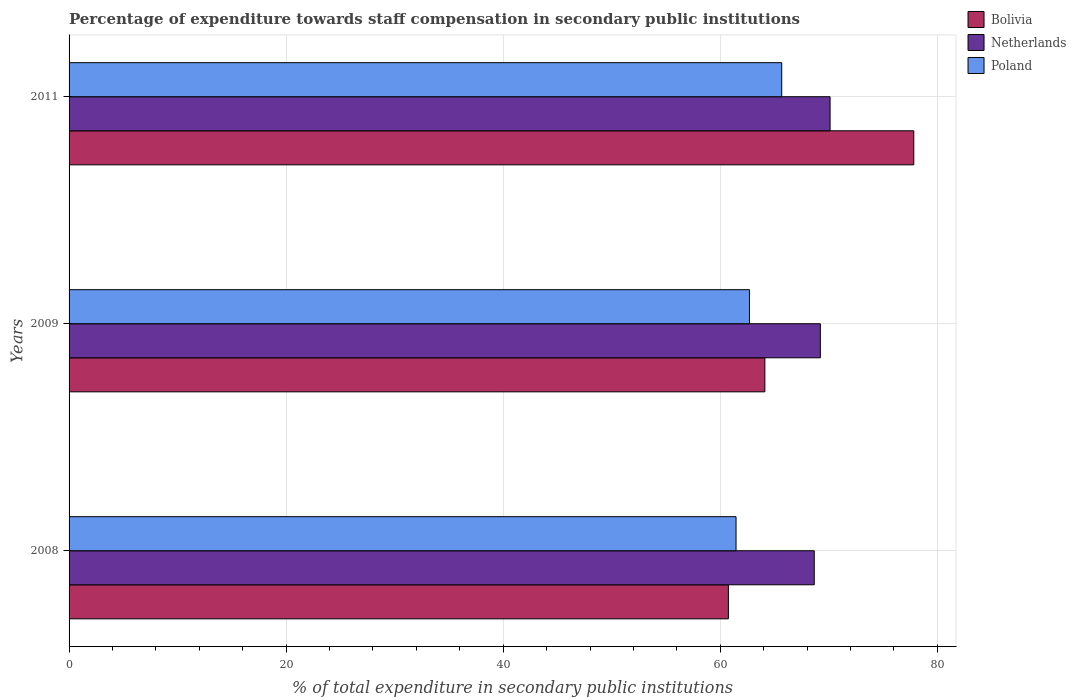How many different coloured bars are there?
Provide a succinct answer. 3. How many groups of bars are there?
Ensure brevity in your answer.  3. Are the number of bars on each tick of the Y-axis equal?
Ensure brevity in your answer.  Yes. How many bars are there on the 2nd tick from the bottom?
Ensure brevity in your answer.  3. What is the label of the 2nd group of bars from the top?
Offer a very short reply. 2009. What is the percentage of expenditure towards staff compensation in Bolivia in 2011?
Your response must be concise. 77.83. Across all years, what is the maximum percentage of expenditure towards staff compensation in Bolivia?
Your answer should be very brief. 77.83. Across all years, what is the minimum percentage of expenditure towards staff compensation in Netherlands?
Ensure brevity in your answer.  68.66. In which year was the percentage of expenditure towards staff compensation in Netherlands minimum?
Ensure brevity in your answer.  2008. What is the total percentage of expenditure towards staff compensation in Poland in the graph?
Your response must be concise. 189.8. What is the difference between the percentage of expenditure towards staff compensation in Bolivia in 2008 and that in 2011?
Give a very brief answer. -17.08. What is the difference between the percentage of expenditure towards staff compensation in Poland in 2011 and the percentage of expenditure towards staff compensation in Bolivia in 2008?
Provide a short and direct response. 4.91. What is the average percentage of expenditure towards staff compensation in Poland per year?
Your answer should be compact. 63.27. In the year 2009, what is the difference between the percentage of expenditure towards staff compensation in Poland and percentage of expenditure towards staff compensation in Bolivia?
Ensure brevity in your answer.  -1.42. What is the ratio of the percentage of expenditure towards staff compensation in Bolivia in 2009 to that in 2011?
Your answer should be compact. 0.82. Is the percentage of expenditure towards staff compensation in Bolivia in 2008 less than that in 2011?
Make the answer very short. Yes. Is the difference between the percentage of expenditure towards staff compensation in Poland in 2009 and 2011 greater than the difference between the percentage of expenditure towards staff compensation in Bolivia in 2009 and 2011?
Your answer should be very brief. Yes. What is the difference between the highest and the second highest percentage of expenditure towards staff compensation in Bolivia?
Make the answer very short. 13.72. What is the difference between the highest and the lowest percentage of expenditure towards staff compensation in Poland?
Provide a succinct answer. 4.21. Is the sum of the percentage of expenditure towards staff compensation in Bolivia in 2009 and 2011 greater than the maximum percentage of expenditure towards staff compensation in Poland across all years?
Ensure brevity in your answer.  Yes. How many bars are there?
Provide a succinct answer. 9. Are all the bars in the graph horizontal?
Give a very brief answer. Yes. What is the difference between two consecutive major ticks on the X-axis?
Give a very brief answer. 20. Where does the legend appear in the graph?
Your answer should be very brief. Top right. How are the legend labels stacked?
Keep it short and to the point. Vertical. What is the title of the graph?
Offer a terse response. Percentage of expenditure towards staff compensation in secondary public institutions. Does "Upper middle income" appear as one of the legend labels in the graph?
Offer a very short reply. No. What is the label or title of the X-axis?
Make the answer very short. % of total expenditure in secondary public institutions. What is the % of total expenditure in secondary public institutions of Bolivia in 2008?
Make the answer very short. 60.75. What is the % of total expenditure in secondary public institutions of Netherlands in 2008?
Give a very brief answer. 68.66. What is the % of total expenditure in secondary public institutions in Poland in 2008?
Ensure brevity in your answer.  61.45. What is the % of total expenditure in secondary public institutions in Bolivia in 2009?
Provide a succinct answer. 64.11. What is the % of total expenditure in secondary public institutions in Netherlands in 2009?
Offer a very short reply. 69.22. What is the % of total expenditure in secondary public institutions in Poland in 2009?
Provide a succinct answer. 62.69. What is the % of total expenditure in secondary public institutions in Bolivia in 2011?
Your response must be concise. 77.83. What is the % of total expenditure in secondary public institutions in Netherlands in 2011?
Provide a succinct answer. 70.11. What is the % of total expenditure in secondary public institutions in Poland in 2011?
Keep it short and to the point. 65.66. Across all years, what is the maximum % of total expenditure in secondary public institutions in Bolivia?
Provide a short and direct response. 77.83. Across all years, what is the maximum % of total expenditure in secondary public institutions in Netherlands?
Give a very brief answer. 70.11. Across all years, what is the maximum % of total expenditure in secondary public institutions in Poland?
Your response must be concise. 65.66. Across all years, what is the minimum % of total expenditure in secondary public institutions in Bolivia?
Offer a terse response. 60.75. Across all years, what is the minimum % of total expenditure in secondary public institutions in Netherlands?
Your answer should be very brief. 68.66. Across all years, what is the minimum % of total expenditure in secondary public institutions in Poland?
Your answer should be compact. 61.45. What is the total % of total expenditure in secondary public institutions of Bolivia in the graph?
Provide a succinct answer. 202.68. What is the total % of total expenditure in secondary public institutions of Netherlands in the graph?
Your answer should be compact. 207.99. What is the total % of total expenditure in secondary public institutions in Poland in the graph?
Provide a succinct answer. 189.8. What is the difference between the % of total expenditure in secondary public institutions in Bolivia in 2008 and that in 2009?
Your response must be concise. -3.36. What is the difference between the % of total expenditure in secondary public institutions in Netherlands in 2008 and that in 2009?
Your response must be concise. -0.56. What is the difference between the % of total expenditure in secondary public institutions in Poland in 2008 and that in 2009?
Offer a very short reply. -1.23. What is the difference between the % of total expenditure in secondary public institutions of Bolivia in 2008 and that in 2011?
Give a very brief answer. -17.08. What is the difference between the % of total expenditure in secondary public institutions in Netherlands in 2008 and that in 2011?
Give a very brief answer. -1.46. What is the difference between the % of total expenditure in secondary public institutions of Poland in 2008 and that in 2011?
Keep it short and to the point. -4.21. What is the difference between the % of total expenditure in secondary public institutions in Bolivia in 2009 and that in 2011?
Give a very brief answer. -13.72. What is the difference between the % of total expenditure in secondary public institutions of Netherlands in 2009 and that in 2011?
Give a very brief answer. -0.9. What is the difference between the % of total expenditure in secondary public institutions in Poland in 2009 and that in 2011?
Make the answer very short. -2.97. What is the difference between the % of total expenditure in secondary public institutions of Bolivia in 2008 and the % of total expenditure in secondary public institutions of Netherlands in 2009?
Your answer should be very brief. -8.47. What is the difference between the % of total expenditure in secondary public institutions in Bolivia in 2008 and the % of total expenditure in secondary public institutions in Poland in 2009?
Offer a very short reply. -1.94. What is the difference between the % of total expenditure in secondary public institutions in Netherlands in 2008 and the % of total expenditure in secondary public institutions in Poland in 2009?
Make the answer very short. 5.97. What is the difference between the % of total expenditure in secondary public institutions of Bolivia in 2008 and the % of total expenditure in secondary public institutions of Netherlands in 2011?
Your answer should be very brief. -9.37. What is the difference between the % of total expenditure in secondary public institutions in Bolivia in 2008 and the % of total expenditure in secondary public institutions in Poland in 2011?
Provide a short and direct response. -4.91. What is the difference between the % of total expenditure in secondary public institutions in Netherlands in 2008 and the % of total expenditure in secondary public institutions in Poland in 2011?
Keep it short and to the point. 3. What is the difference between the % of total expenditure in secondary public institutions in Bolivia in 2009 and the % of total expenditure in secondary public institutions in Netherlands in 2011?
Your answer should be compact. -6.01. What is the difference between the % of total expenditure in secondary public institutions in Bolivia in 2009 and the % of total expenditure in secondary public institutions in Poland in 2011?
Provide a short and direct response. -1.55. What is the difference between the % of total expenditure in secondary public institutions in Netherlands in 2009 and the % of total expenditure in secondary public institutions in Poland in 2011?
Your response must be concise. 3.56. What is the average % of total expenditure in secondary public institutions in Bolivia per year?
Your answer should be very brief. 67.56. What is the average % of total expenditure in secondary public institutions in Netherlands per year?
Offer a very short reply. 69.33. What is the average % of total expenditure in secondary public institutions of Poland per year?
Offer a very short reply. 63.27. In the year 2008, what is the difference between the % of total expenditure in secondary public institutions of Bolivia and % of total expenditure in secondary public institutions of Netherlands?
Your answer should be compact. -7.91. In the year 2008, what is the difference between the % of total expenditure in secondary public institutions of Bolivia and % of total expenditure in secondary public institutions of Poland?
Make the answer very short. -0.71. In the year 2008, what is the difference between the % of total expenditure in secondary public institutions in Netherlands and % of total expenditure in secondary public institutions in Poland?
Ensure brevity in your answer.  7.2. In the year 2009, what is the difference between the % of total expenditure in secondary public institutions in Bolivia and % of total expenditure in secondary public institutions in Netherlands?
Provide a succinct answer. -5.11. In the year 2009, what is the difference between the % of total expenditure in secondary public institutions of Bolivia and % of total expenditure in secondary public institutions of Poland?
Offer a very short reply. 1.42. In the year 2009, what is the difference between the % of total expenditure in secondary public institutions in Netherlands and % of total expenditure in secondary public institutions in Poland?
Provide a short and direct response. 6.53. In the year 2011, what is the difference between the % of total expenditure in secondary public institutions in Bolivia and % of total expenditure in secondary public institutions in Netherlands?
Offer a very short reply. 7.71. In the year 2011, what is the difference between the % of total expenditure in secondary public institutions in Bolivia and % of total expenditure in secondary public institutions in Poland?
Your response must be concise. 12.17. In the year 2011, what is the difference between the % of total expenditure in secondary public institutions of Netherlands and % of total expenditure in secondary public institutions of Poland?
Your response must be concise. 4.45. What is the ratio of the % of total expenditure in secondary public institutions in Bolivia in 2008 to that in 2009?
Ensure brevity in your answer.  0.95. What is the ratio of the % of total expenditure in secondary public institutions in Poland in 2008 to that in 2009?
Provide a short and direct response. 0.98. What is the ratio of the % of total expenditure in secondary public institutions of Bolivia in 2008 to that in 2011?
Your response must be concise. 0.78. What is the ratio of the % of total expenditure in secondary public institutions in Netherlands in 2008 to that in 2011?
Offer a terse response. 0.98. What is the ratio of the % of total expenditure in secondary public institutions of Poland in 2008 to that in 2011?
Offer a terse response. 0.94. What is the ratio of the % of total expenditure in secondary public institutions in Bolivia in 2009 to that in 2011?
Keep it short and to the point. 0.82. What is the ratio of the % of total expenditure in secondary public institutions of Netherlands in 2009 to that in 2011?
Your answer should be compact. 0.99. What is the ratio of the % of total expenditure in secondary public institutions in Poland in 2009 to that in 2011?
Provide a succinct answer. 0.95. What is the difference between the highest and the second highest % of total expenditure in secondary public institutions of Bolivia?
Your response must be concise. 13.72. What is the difference between the highest and the second highest % of total expenditure in secondary public institutions of Netherlands?
Provide a succinct answer. 0.9. What is the difference between the highest and the second highest % of total expenditure in secondary public institutions of Poland?
Offer a very short reply. 2.97. What is the difference between the highest and the lowest % of total expenditure in secondary public institutions of Bolivia?
Provide a succinct answer. 17.08. What is the difference between the highest and the lowest % of total expenditure in secondary public institutions in Netherlands?
Give a very brief answer. 1.46. What is the difference between the highest and the lowest % of total expenditure in secondary public institutions of Poland?
Your response must be concise. 4.21. 